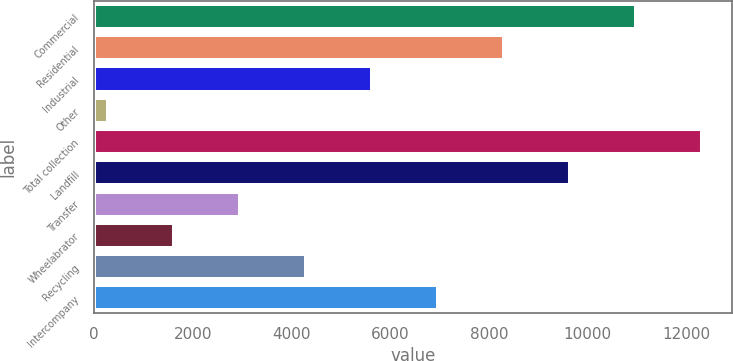<chart> <loc_0><loc_0><loc_500><loc_500><bar_chart><fcel>Commercial<fcel>Residential<fcel>Industrial<fcel>Other<fcel>Total collection<fcel>Landfill<fcel>Transfer<fcel>Wheelabrator<fcel>Recycling<fcel>Intercompany<nl><fcel>10974.2<fcel>8299.4<fcel>5624.6<fcel>275<fcel>12311.6<fcel>9636.8<fcel>2949.8<fcel>1612.4<fcel>4287.2<fcel>6962<nl></chart> 